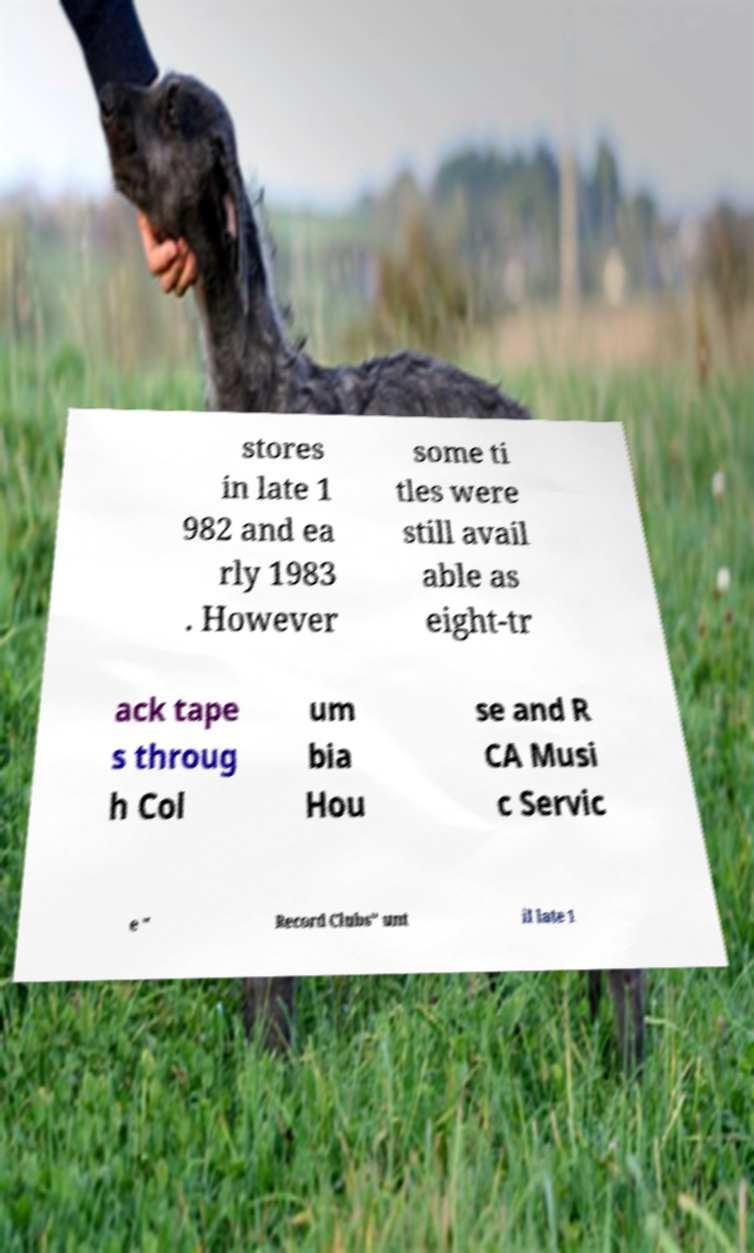Please identify and transcribe the text found in this image. stores in late 1 982 and ea rly 1983 . However some ti tles were still avail able as eight-tr ack tape s throug h Col um bia Hou se and R CA Musi c Servic e " Record Clubs" unt il late 1 